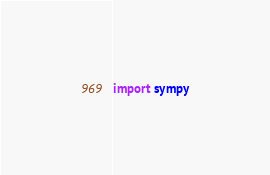<code> <loc_0><loc_0><loc_500><loc_500><_Python_>import sympy</code> 